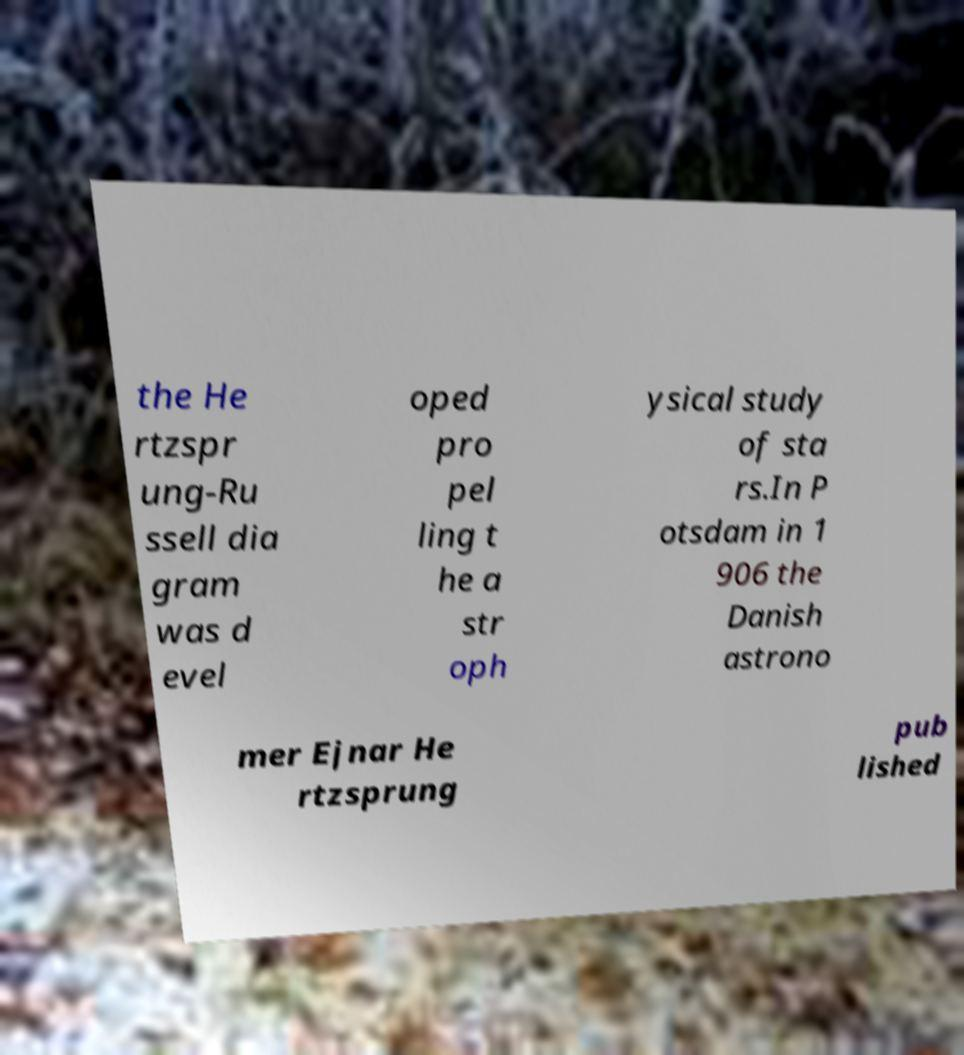Please read and relay the text visible in this image. What does it say? the He rtzspr ung-Ru ssell dia gram was d evel oped pro pel ling t he a str oph ysical study of sta rs.In P otsdam in 1 906 the Danish astrono mer Ejnar He rtzsprung pub lished 